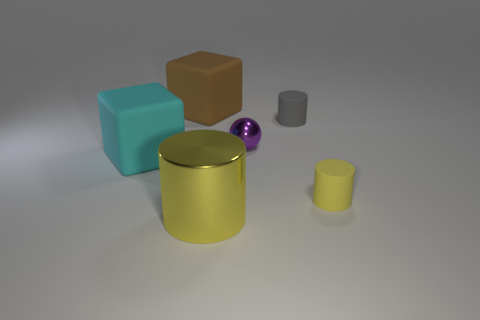What is the color of the other rubber object that is the same size as the gray thing? yellow 